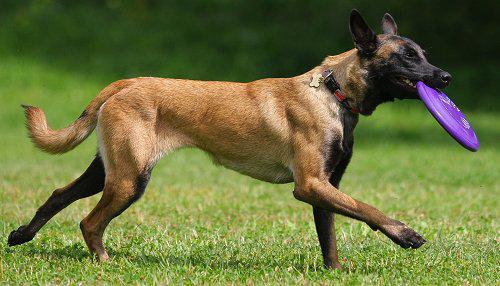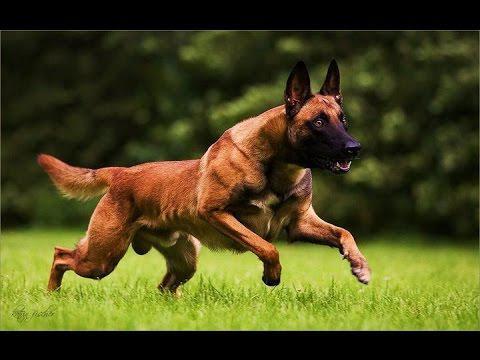The first image is the image on the left, the second image is the image on the right. Examine the images to the left and right. Is the description "There is a dog looking off to the left." accurate? Answer yes or no. No. The first image is the image on the left, the second image is the image on the right. Considering the images on both sides, is "One of the dogs is carrying a toy in it's mouth." valid? Answer yes or no. Yes. The first image is the image on the left, the second image is the image on the right. Analyze the images presented: Is the assertion "the anilmal's tongue is extended in one of the images" valid? Answer yes or no. No. 